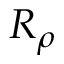<formula> <loc_0><loc_0><loc_500><loc_500>R _ { \rho }</formula> 